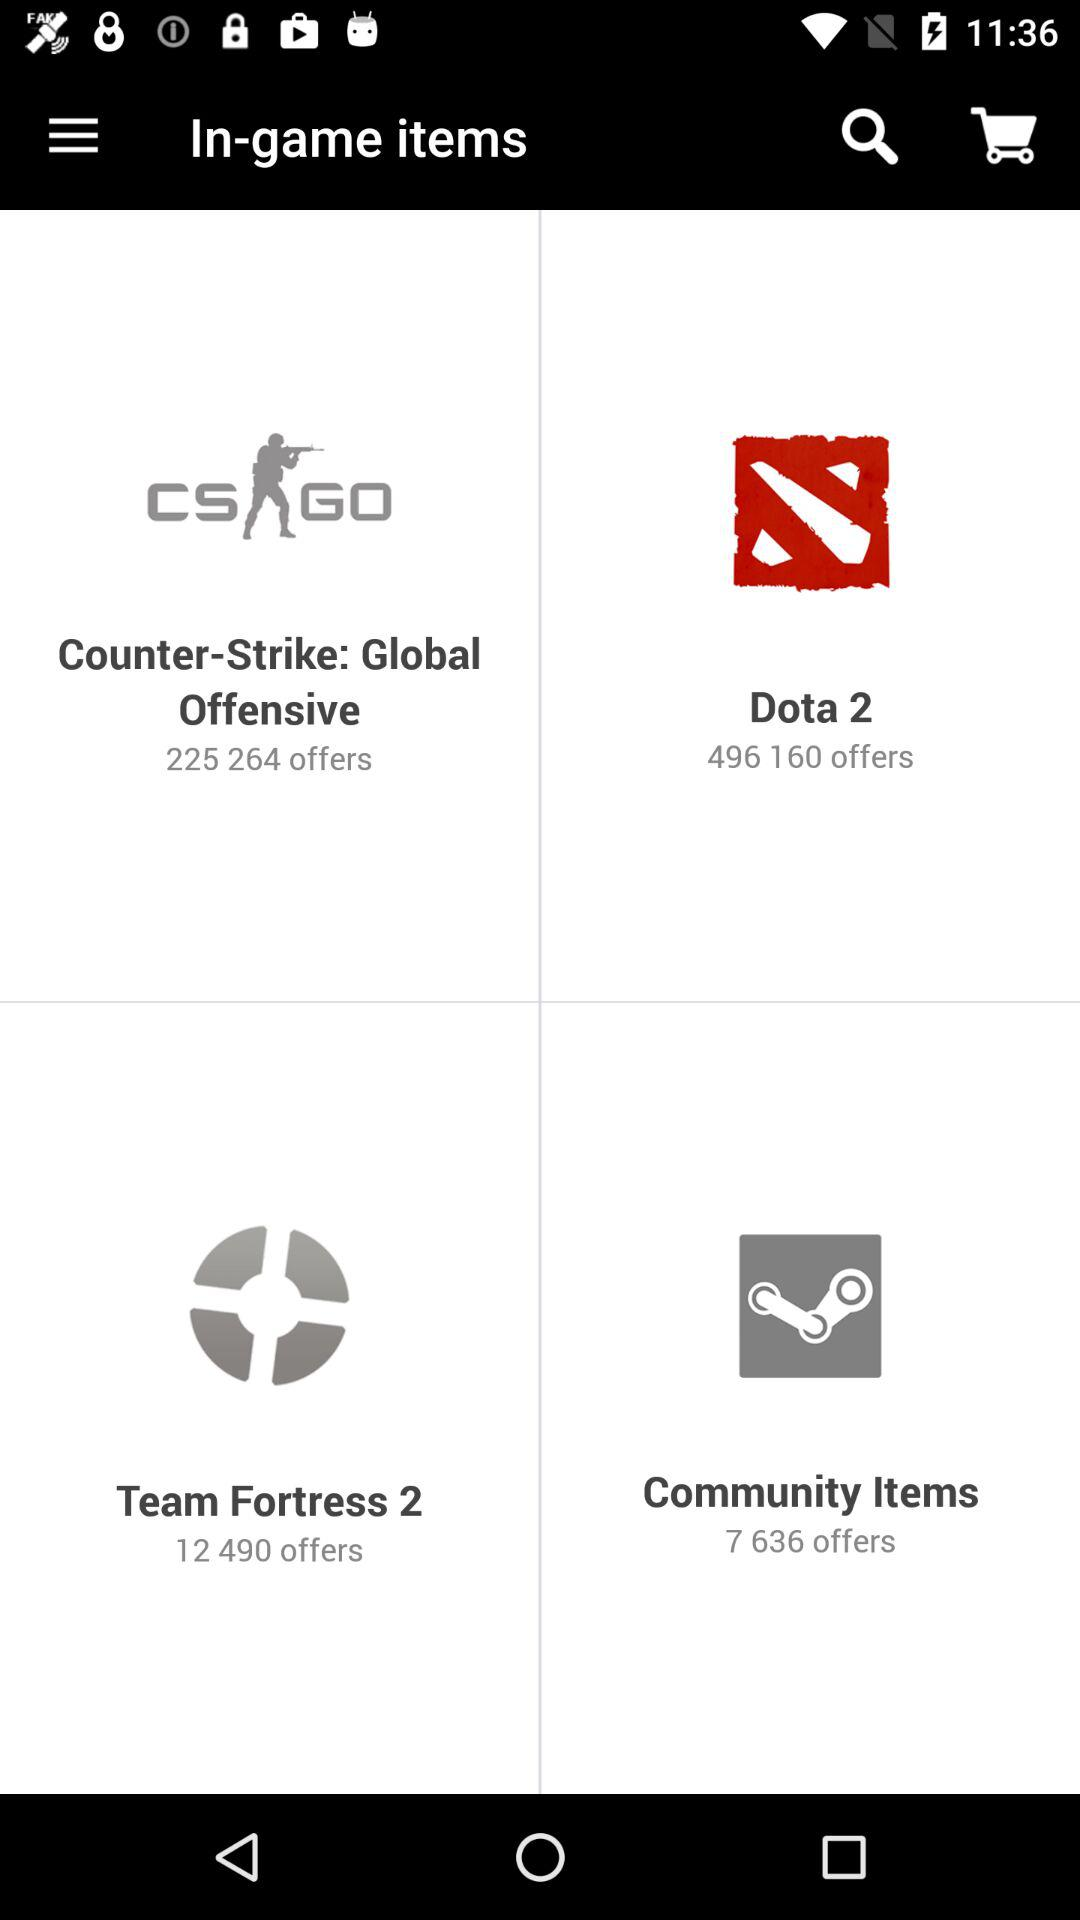How many offers are available in "Dota 2"? There are 4,961,160 offers available in "Dota 2". 